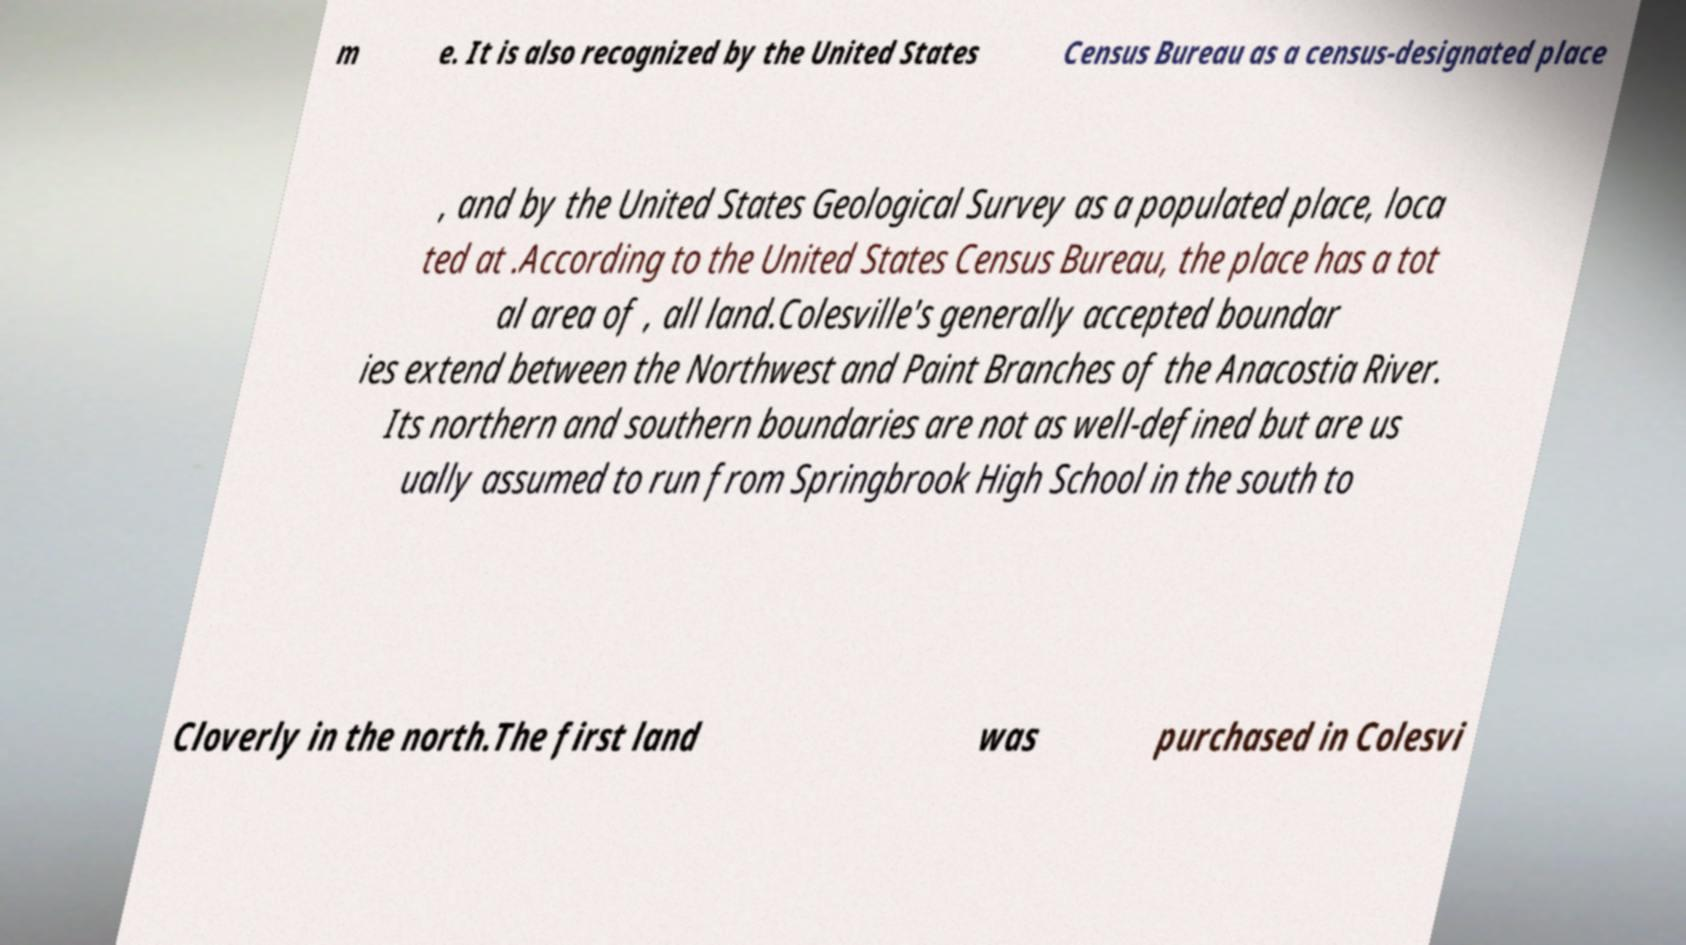Please identify and transcribe the text found in this image. m e. It is also recognized by the United States Census Bureau as a census-designated place , and by the United States Geological Survey as a populated place, loca ted at .According to the United States Census Bureau, the place has a tot al area of , all land.Colesville's generally accepted boundar ies extend between the Northwest and Paint Branches of the Anacostia River. Its northern and southern boundaries are not as well-defined but are us ually assumed to run from Springbrook High School in the south to Cloverly in the north.The first land was purchased in Colesvi 